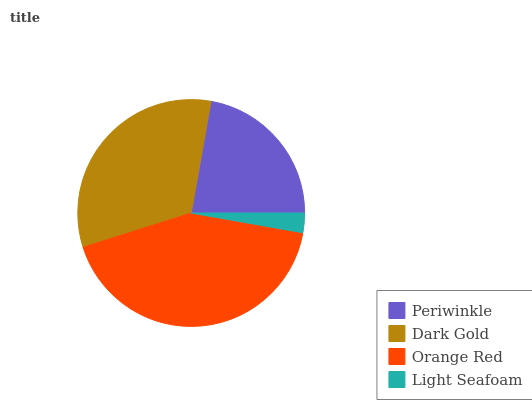Is Light Seafoam the minimum?
Answer yes or no. Yes. Is Orange Red the maximum?
Answer yes or no. Yes. Is Dark Gold the minimum?
Answer yes or no. No. Is Dark Gold the maximum?
Answer yes or no. No. Is Dark Gold greater than Periwinkle?
Answer yes or no. Yes. Is Periwinkle less than Dark Gold?
Answer yes or no. Yes. Is Periwinkle greater than Dark Gold?
Answer yes or no. No. Is Dark Gold less than Periwinkle?
Answer yes or no. No. Is Dark Gold the high median?
Answer yes or no. Yes. Is Periwinkle the low median?
Answer yes or no. Yes. Is Periwinkle the high median?
Answer yes or no. No. Is Dark Gold the low median?
Answer yes or no. No. 